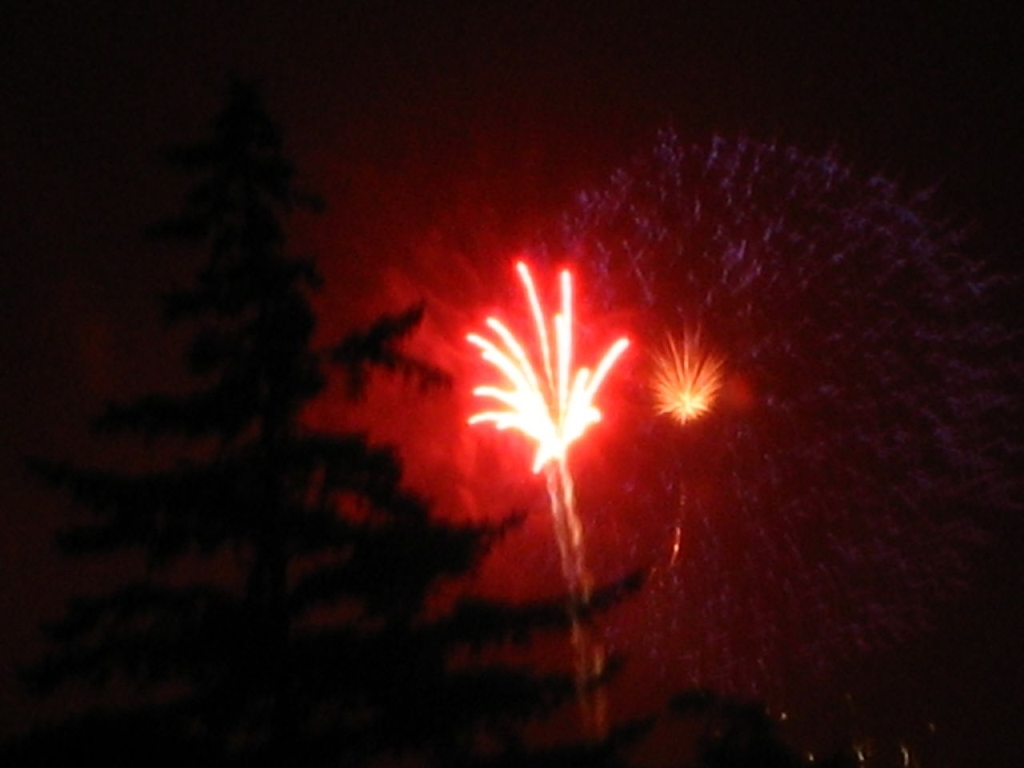How might the time of year or location affect the perception of this image? If captured during a holiday known for fireworks, such as New Year's Eve or the Fourth of July, viewers might associate it with those celebrations. The silhouette of the tree could suggest it's not in an urban setting, perhaps in a place where such displays are less common, adding to its uniqueness. The viewing experience could also vary with the cultural or regional significance of fireworks displays. 